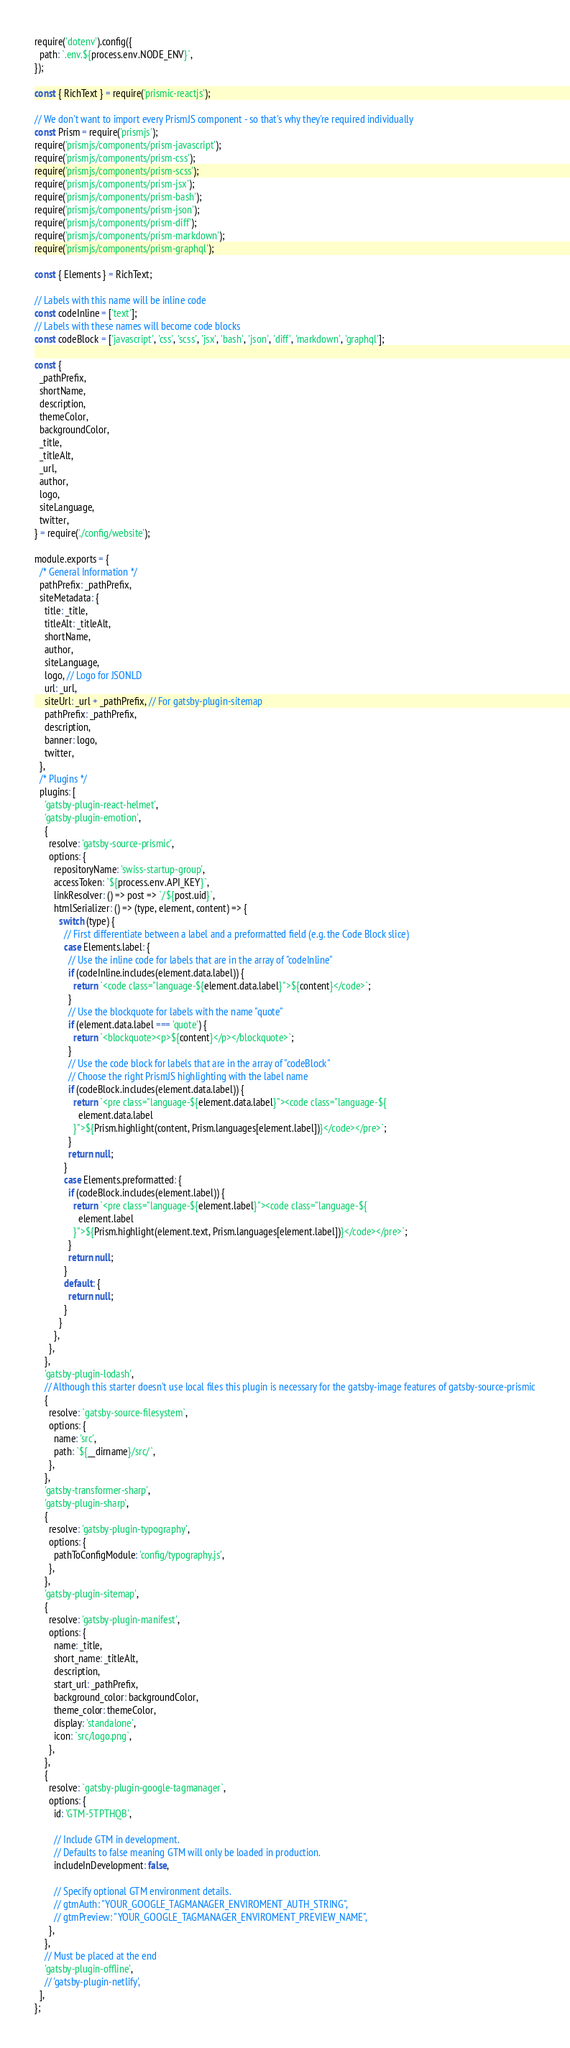<code> <loc_0><loc_0><loc_500><loc_500><_JavaScript_>require('dotenv').config({
  path: `.env.${process.env.NODE_ENV}`,
});

const { RichText } = require('prismic-reactjs');

// We don't want to import every PrismJS component - so that's why they're required individually
const Prism = require('prismjs');
require('prismjs/components/prism-javascript');
require('prismjs/components/prism-css');
require('prismjs/components/prism-scss');
require('prismjs/components/prism-jsx');
require('prismjs/components/prism-bash');
require('prismjs/components/prism-json');
require('prismjs/components/prism-diff');
require('prismjs/components/prism-markdown');
require('prismjs/components/prism-graphql');

const { Elements } = RichText;

// Labels with this name will be inline code
const codeInline = ['text'];
// Labels with these names will become code blocks
const codeBlock = ['javascript', 'css', 'scss', 'jsx', 'bash', 'json', 'diff', 'markdown', 'graphql'];

const {
  _pathPrefix,
  shortName,
  description,
  themeColor,
  backgroundColor,
  _title,
  _titleAlt,
  _url,
  author,
  logo,
  siteLanguage,
  twitter,
} = require('./config/website');

module.exports = {
  /* General Information */
  pathPrefix: _pathPrefix,
  siteMetadata: {
    title: _title,
    titleAlt: _titleAlt,
    shortName,
    author,
    siteLanguage,
    logo, // Logo for JSONLD
    url: _url,
    siteUrl: _url + _pathPrefix, // For gatsby-plugin-sitemap
    pathPrefix: _pathPrefix,
    description,
    banner: logo,
    twitter,
  },
  /* Plugins */
  plugins: [
    'gatsby-plugin-react-helmet',
    'gatsby-plugin-emotion',
    {
      resolve: 'gatsby-source-prismic',
      options: {
        repositoryName: 'swiss-startup-group',
        accessToken: `${process.env.API_KEY}`,
        linkResolver: () => post => `/${post.uid}`,
        htmlSerializer: () => (type, element, content) => {
          switch (type) {
            // First differentiate between a label and a preformatted field (e.g. the Code Block slice)
            case Elements.label: {
              // Use the inline code for labels that are in the array of "codeInline"
              if (codeInline.includes(element.data.label)) {
                return `<code class="language-${element.data.label}">${content}</code>`;
              }
              // Use the blockquote for labels with the name "quote"
              if (element.data.label === 'quote') {
                return `<blockquote><p>${content}</p></blockquote>`;
              }
              // Use the code block for labels that are in the array of "codeBlock"
              // Choose the right PrismJS highlighting with the label name
              if (codeBlock.includes(element.data.label)) {
                return `<pre class="language-${element.data.label}"><code class="language-${
                  element.data.label
                }">${Prism.highlight(content, Prism.languages[element.label])}</code></pre>`;
              }
              return null;
            }
            case Elements.preformatted: {
              if (codeBlock.includes(element.label)) {
                return `<pre class="language-${element.label}"><code class="language-${
                  element.label
                }">${Prism.highlight(element.text, Prism.languages[element.label])}</code></pre>`;
              }
              return null;
            }
            default: {
              return null;
            }
          }
        },
      },
    },
    'gatsby-plugin-lodash',
    // Although this starter doesn't use local files this plugin is necessary for the gatsby-image features of gatsby-source-prismic
    {
      resolve: `gatsby-source-filesystem`,
      options: {
        name: 'src',
        path: `${__dirname}/src/`,
      },
    },
    'gatsby-transformer-sharp',
    'gatsby-plugin-sharp',
    {
      resolve: 'gatsby-plugin-typography',
      options: {
        pathToConfigModule: 'config/typography.js',
      },
    },
    'gatsby-plugin-sitemap',
    {
      resolve: 'gatsby-plugin-manifest',
      options: {
        name: _title,
        short_name: _titleAlt,
        description,
        start_url: _pathPrefix,
        background_color: backgroundColor,
        theme_color: themeColor,
        display: 'standalone',
        icon: `src/logo.png`,
      },
    },
    {
      resolve: `gatsby-plugin-google-tagmanager`,
      options: {
        id: 'GTM-5TPTHQB',

        // Include GTM in development.
        // Defaults to false meaning GTM will only be loaded in production.
        includeInDevelopment: false,

        // Specify optional GTM environment details.
        // gtmAuth: "YOUR_GOOGLE_TAGMANAGER_ENVIROMENT_AUTH_STRING",
        // gtmPreview: "YOUR_GOOGLE_TAGMANAGER_ENVIROMENT_PREVIEW_NAME",
      },
    },
    // Must be placed at the end
    'gatsby-plugin-offline',
    // 'gatsby-plugin-netlify',
  ],
};
</code> 